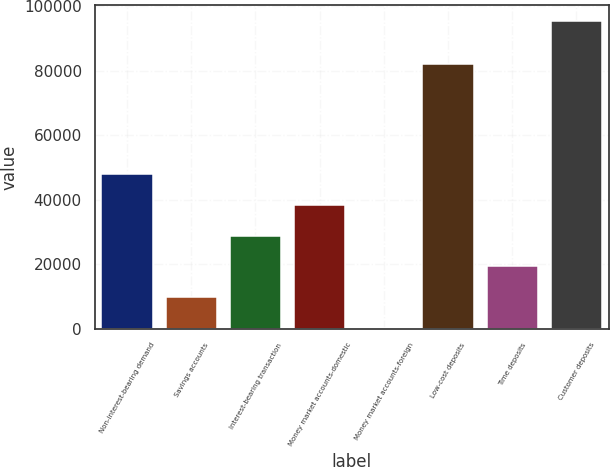Convert chart. <chart><loc_0><loc_0><loc_500><loc_500><bar_chart><fcel>Non-interest-bearing demand<fcel>Savings accounts<fcel>Interest-bearing transaction<fcel>Money market accounts-domestic<fcel>Money market accounts-foreign<fcel>Low-cost deposits<fcel>Time deposits<fcel>Customer deposits<nl><fcel>47892.5<fcel>9827.3<fcel>28859.9<fcel>38376.2<fcel>311<fcel>82031<fcel>19343.6<fcel>95474<nl></chart> 